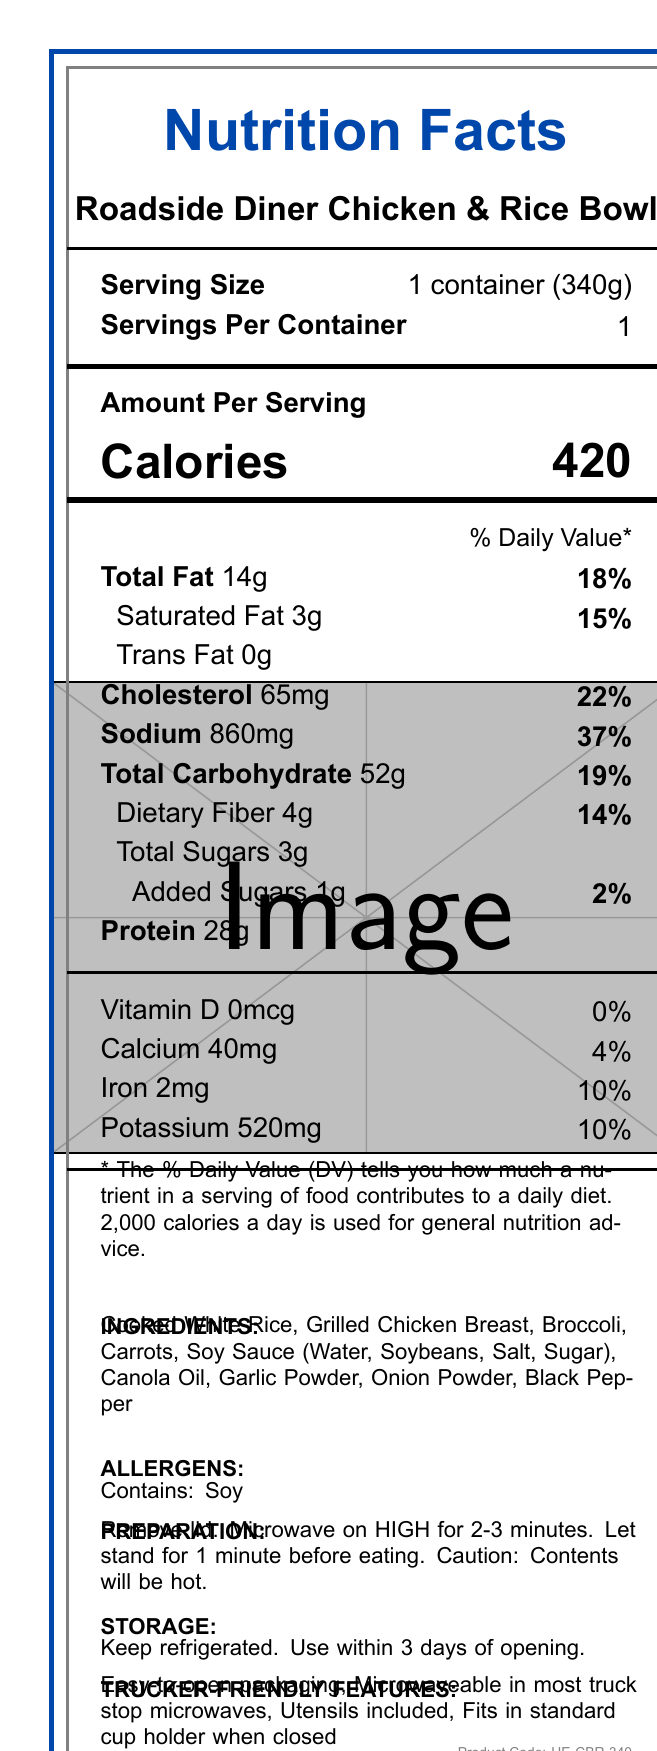what is the serving size of the Roadside Diner Chicken & Rice Bowl? The serving size is explicitly stated in the document as "1 container (340g)".
Answer: 1 container (340g) how much sodium does one serving contain? The sodium content is listed as 860mg per serving on the document.
Answer: 860mg what is the daily value percentage of sodium in one serving? The document mentions that the sodium contributes 37% to the daily value.
Answer: 37% how many total carbohydrates are in the Roadside Diner Chicken & Rice Bowl? The total carbohydrate content is listed as 52g per serving on the document.
Answer: 52g what are the preparation instructions for the meal? The preparation instructions are explicitly mentioned in a dedicated section of the document.
Answer: Remove lid. Microwave on HIGH for 2-3 minutes. Let stand for 1 minute before eating. Caution: Contents will be hot. how many servings are in one container? A. 2 B. 1 C. 4 D. 3 The document states that there is 1 serving per container.
Answer: B. 1 what is the percentage of the daily value for total fat? A. 22% B. 2% C. 37% D. 18% The total fat daily value percentage is listed as 18% in the document.
Answer: D. 18% is this meal a good source of protein? The meal contains 28g of protein, which is relatively high, indicating it's a good source of protein.
Answer: Yes does the product contain any allergens? The document states that the product contains soy.
Answer: Yes what features make this meal trucker-friendly? The document lists specific trucker-friendly features such as easy-to-open packaging and being microwaveable in most truck stop microwaves.
Answer: Easy-to-open packaging, Microwaveable in most truck stop microwaves, Utensils included, Fits in standard cup holder when closed what is the main idea of this document? The document comprehensively details various aspects of the Roadside Diner Chicken & Rice Bowl, targeted for truck drivers.
Answer: The document provides detailed nutritional information, preparation and storage instructions, allergen information, and trucker-friendly features for the Roadside Diner Chicken & Rice Bowl. how much vitamin D is in the meal? The document lists the vitamin D content as 0mcg.
Answer: 0mcg what are the main ingredients of the Roadside Diner Chicken & Rice Bowl? The ingredients section of the document provides a complete list of what is included in the meal.
Answer: Cooked White Rice, Grilled Chicken Breast, Broccoli, Carrots, Soy Sauce (Water, Soybeans, Salt, Sugar), Canola Oil, Garlic Powder, Onion Powder, Black Pepper what is the cholesterol content per serving? The document specifies that the cholesterol content is 65mg per serving.
Answer: 65mg how should the meal be stored? The storage instructions clearly state to keep the meal refrigerated and to use it within 3 days of opening.
Answer: Keep refrigerated. Use within 3 days of opening. what is the product code for the Roadside Diner Chicken & Rice Bowl? The product code listed in the document is "HE-CBR-340".
Answer: HE-CBR-340 when should you let the meal stand? The preparation instructions indicate that you should let the meal stand for 1 minute after microwaving.
Answer: After microwaving for 2-3 minutes can this meal be cooked in any microwave? The document specifies it is microwaveable in most truck stop microwaves but does not provide information about all microwaves.
Answer: Not enough information 